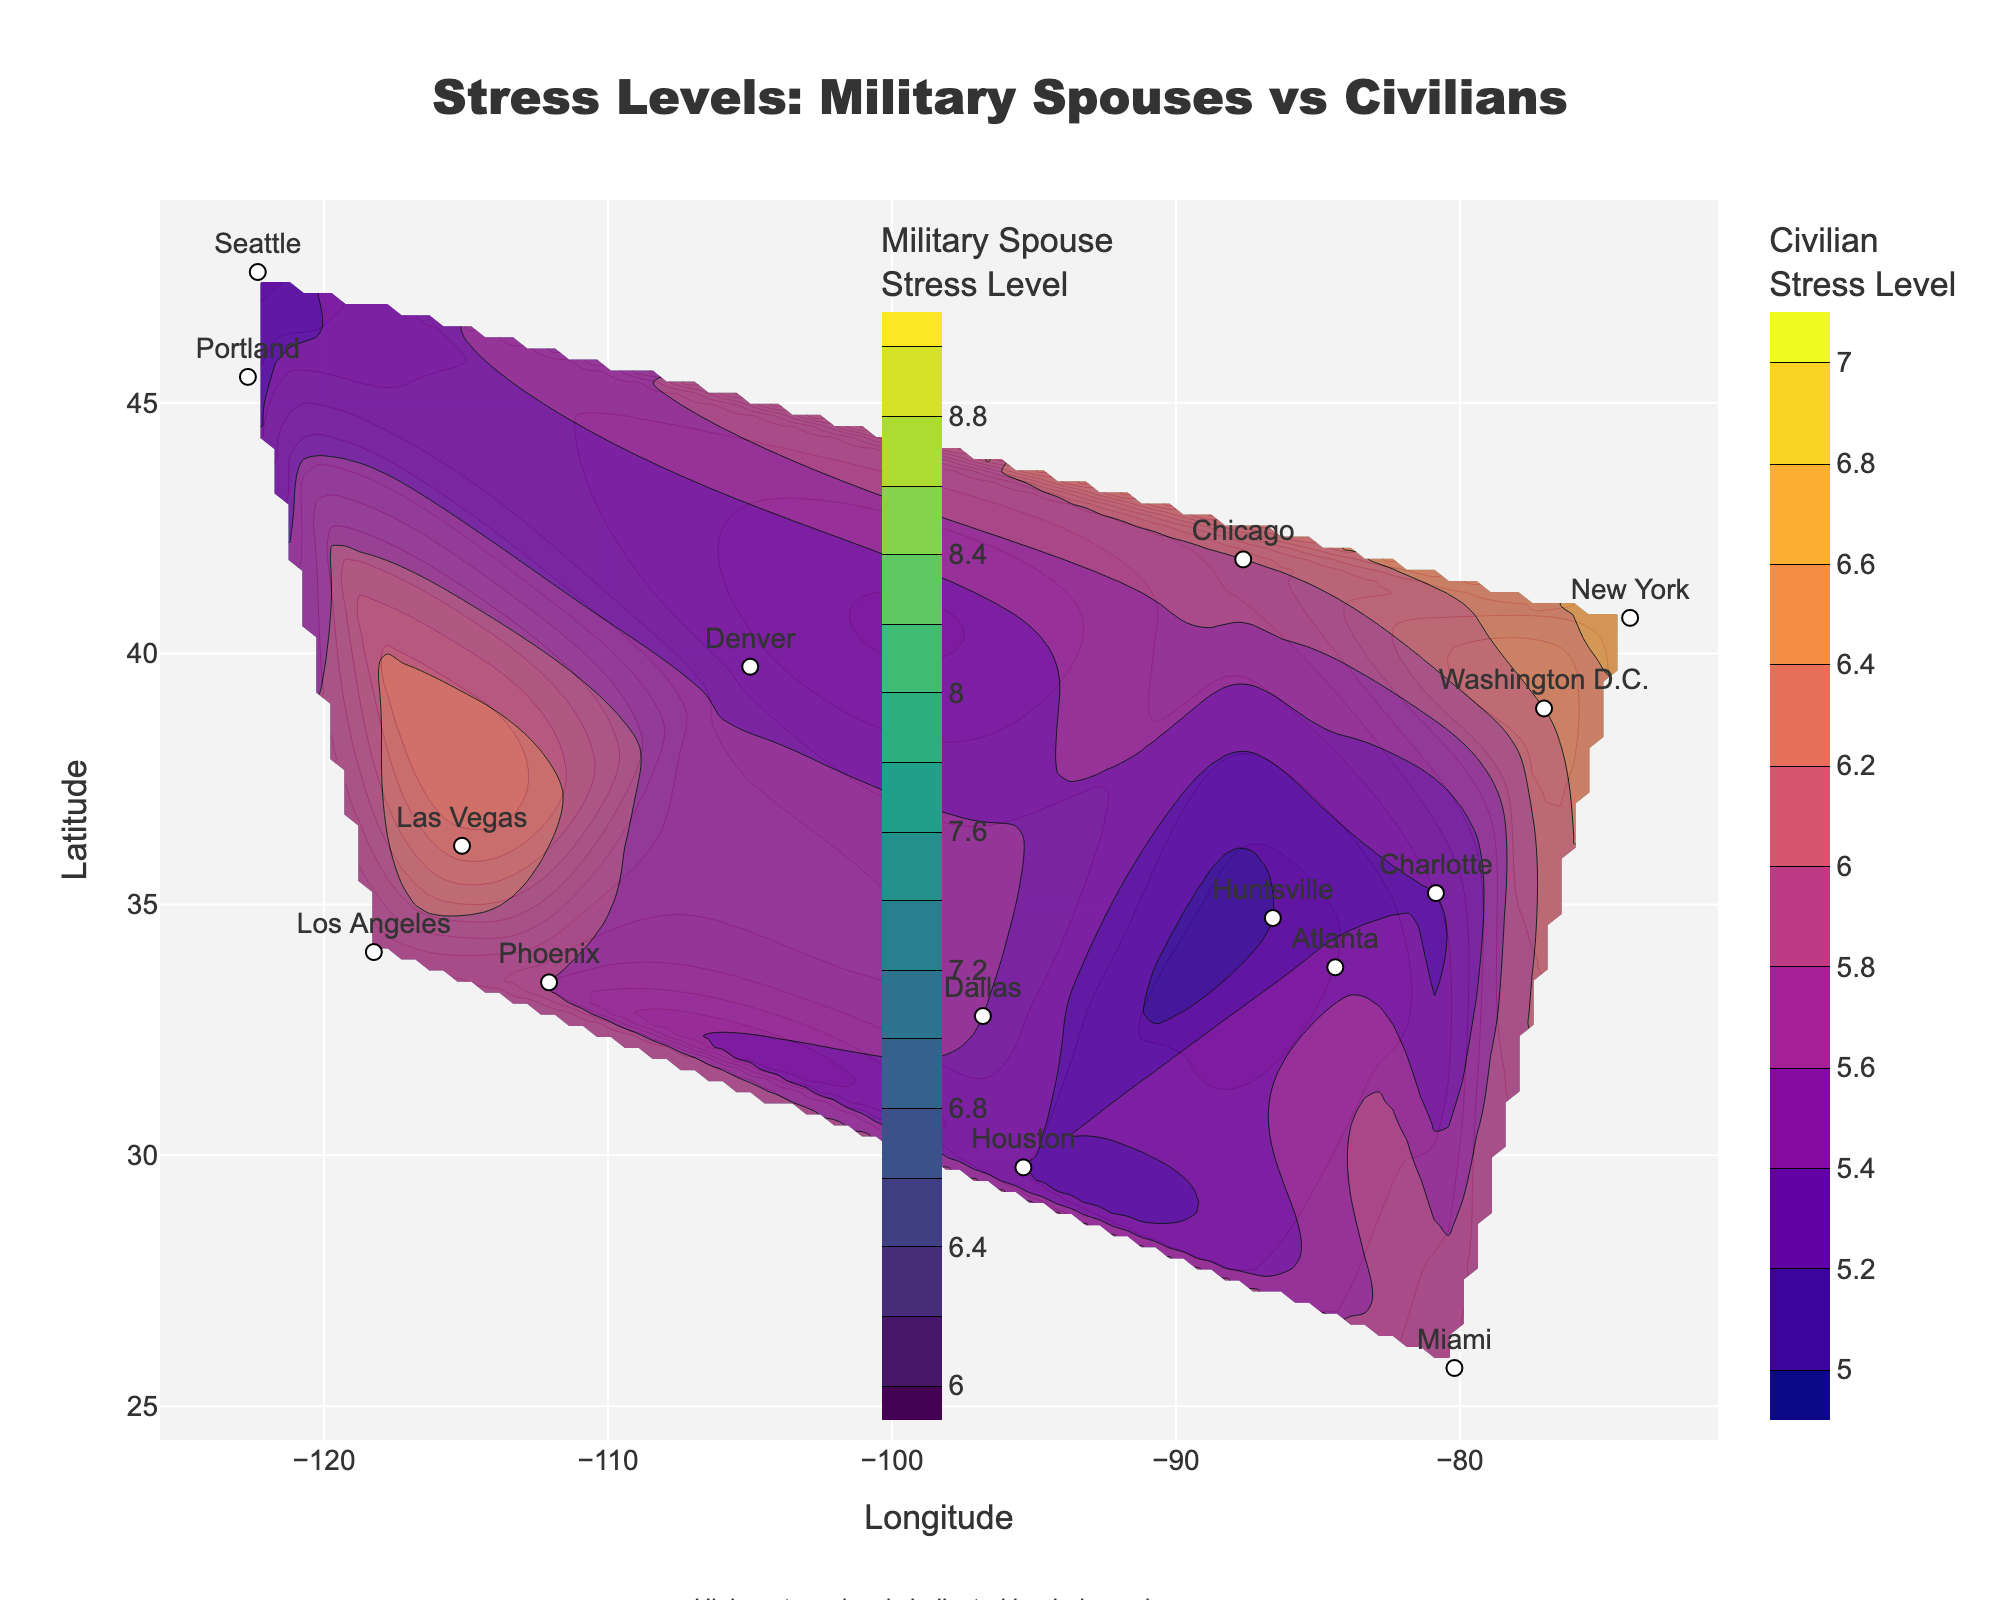What is the title of the contour plot? The title of the contour plot can be found at the top center of the figure. It reads, "Stress Levels: Military Spouses vs Civilians".
Answer: Stress Levels: Military Spouses vs Civilians Which color scale is used for military spouse stress levels? The color scale for military spouse stress levels is indicated in the legend next to the color bar. It uses the 'Viridis' color scale.
Answer: Viridis What are the stress level ranges illustrated in the contour plot for civilians? The contour plot for civilians uses a range from the minimum value of 5 to the maximum value of 7, as indicated by the contours and color scale.
Answer: 5 to 7 Which location has the highest stress level for military spouses, and what is that level? By checking the highest contours on the plot, we can see that Las Vegas has the highest stress level for military spouses, which is 8.5.
Answer: Las Vegas, 8.5 Compare the stress levels of military spouses and civilians in Miami. Which group has higher stress levels? The stress levels for Miami can be found along the latitude 25.7617 and longitude -80.1918. Military spouses have a stress level of 7.4 while civilians have a stress level of 6.0. Military spouses have a higher stress level.
Answer: Military spouses What can be inferred about the overall stress levels for military spouses compared to civilians? By observing the contour color scales, the general observation is that the stress levels for military spouses are consistently higher compared to civilians across all locations.
Answer: Military spouses have higher stress levels Which city among those listed shows the smallest difference in stress levels between military spouses and civilians? Compute the difference in stress levels for each city then identify the smallest value. For Chicago (7.3 - 6.0), the difference is 1.3. This is the smallest among all cities.
Answer: Chicago Describe the trend of stress levels for civilians from west to east. Observing the color shading on the contour lines, the civilian stress levels start from lower values in the west and gradually increase as we move eastward across the United States.
Answer: Increasing trend from west to east Based on the plot, which city is depicted as having the least stress for both military spouses and civilians? By comparing the lowest contours for both military spouses and civilians, Seattle shows the least stress levels, with military spouses at 6.5 and civilians at 5.3.
Answer: Seattle 